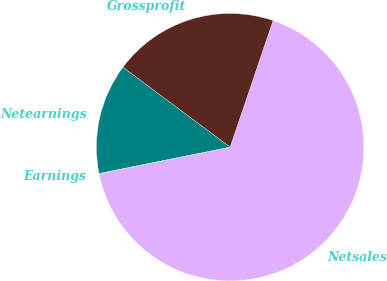Convert chart to OTSL. <chart><loc_0><loc_0><loc_500><loc_500><pie_chart><fcel>Netsales<fcel>Grossprofit<fcel>Netearnings<fcel>Earnings<nl><fcel>66.6%<fcel>20.01%<fcel>13.35%<fcel>0.04%<nl></chart> 